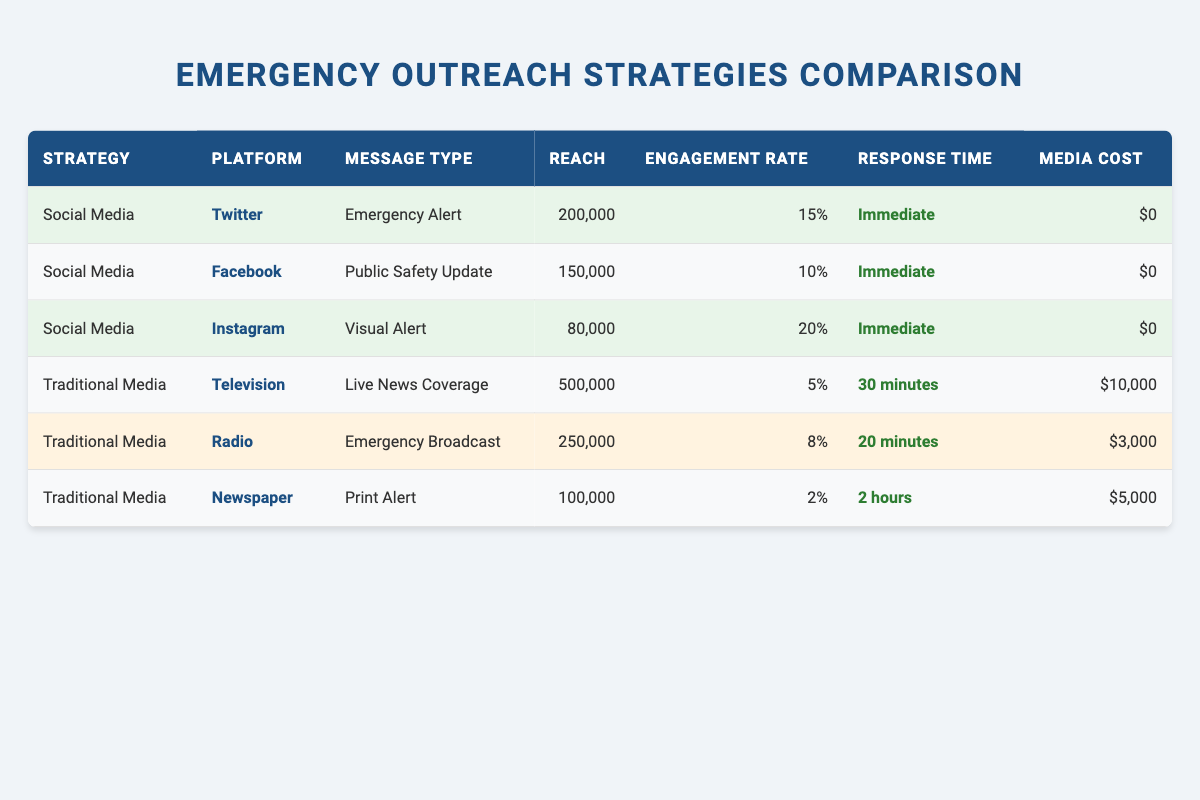What is the reach of the emergency alert through Twitter? According to the table, Twitter, as a social media strategy, has a reach of 200,000 for the emergency alert message type.
Answer: 200,000 What is the engagement rate of the public safety update on Facebook? The table specifies that Facebook has an engagement rate of 10% for the public safety update message type.
Answer: 10% Which outreach strategy has the longest response time? In the table, the newspaper shows a response time of 2 hours, which is the longest among all listed strategies.
Answer: Newspaper What is the total reach of all social media platforms combined? To find the total reach of social media platforms: 200,000 (Twitter) + 150,000 (Facebook) + 80,000 (Instagram) = 430,000.
Answer: 430,000 Is the media cost for traditional media higher than for social media? The media cost for all social media platforms is $0, while traditional media has costs of $10,000 (Television), $3,000 (Radio), and $5,000 (Newspaper), which all exceed $0.
Answer: Yes What is the average engagement rate of traditional media? The engagement rates for traditional media are 5% (Television), 8% (Radio), and 2% (Newspaper). The average is calculated as (5 + 8 + 2) / 3 = 5%.
Answer: 5% Which platform has the highest engagement rate, and what is that rate? From the table, Instagram has the highest engagement rate at 20% for the visual alert message type.
Answer: Instagram, 20% How much does it cost to use traditional media for an emergency broadcast? The table states that the radio, which uses traditional media for the emergency broadcast, costs $3,000.
Answer: $3,000 Is the reach of live news coverage on television greater than both Facebook and Instagram combined? The reach of Television is 500,000, while the combined reach of Facebook (150,000) and Instagram (80,000) is 230,000, which is less than 500,000.
Answer: Yes 